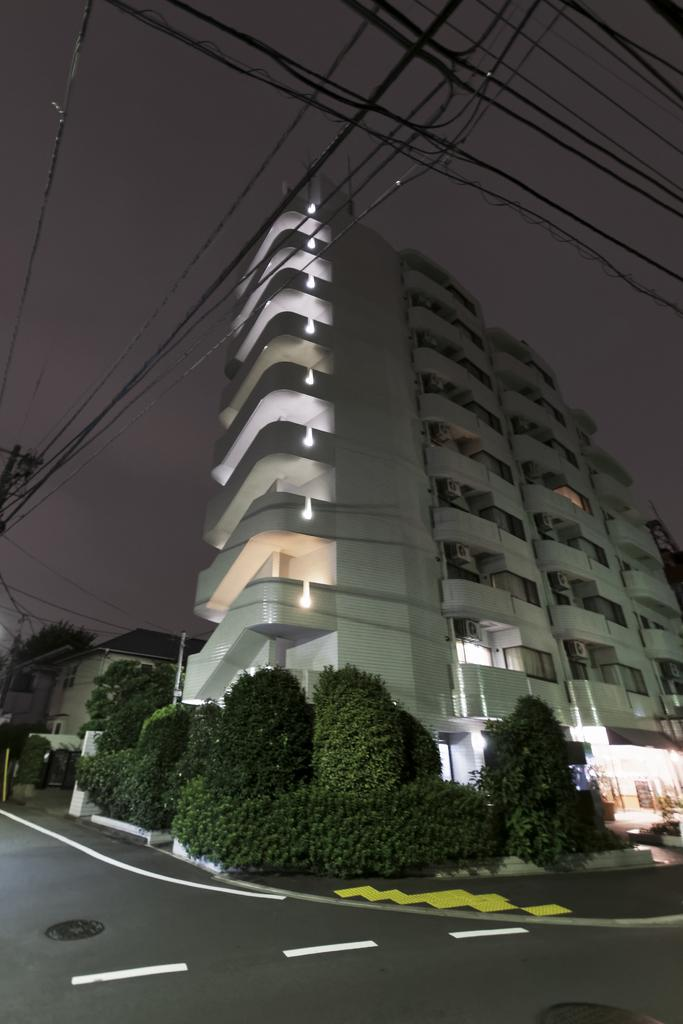What type of structures can be seen in the image? There are buildings in the image. What else can be seen besides the buildings? There are plants and poles with wires attached in the image. What might indicate the presence of a road in the image? White lines are visible on the road. What can be seen in the background of the image? The sky is visible in the background of the image. What type of locket is the grandmother wearing in the image? There is no grandmother or locket present in the image. How does the paste help in the image? There is no paste present in the image, so it cannot help in any way. 